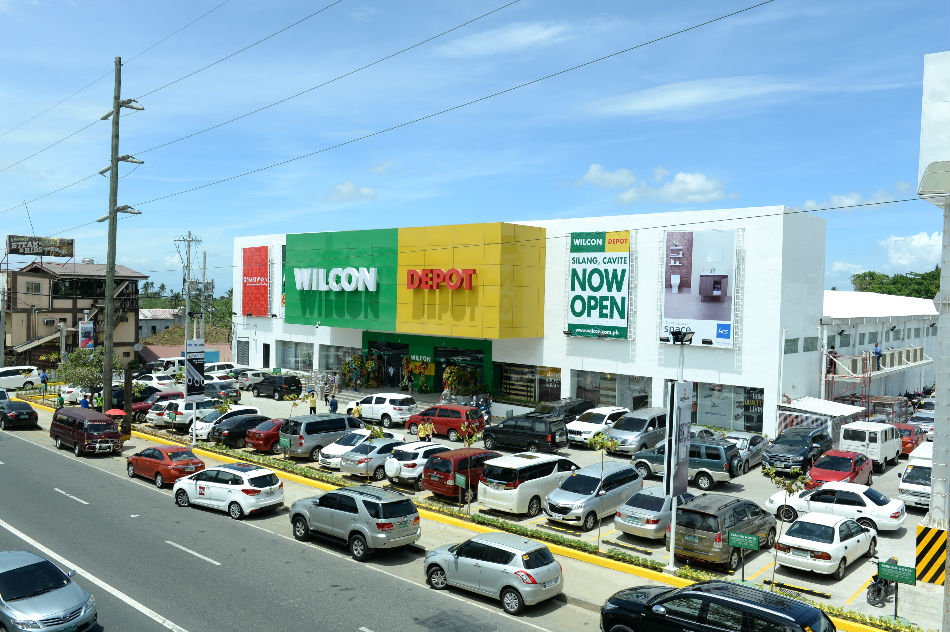Given the number of parked cars and visible people around the commercial building, what can be inferred about the popularity and potential business volume of the establishment on the day the photo was taken? The presence of a large number of parked cars and several people visible near the entrance of the commercial building suggests high customer turnout. This observation, combined with the 'NOW OPEN' banner, indicates that the establishment might have recently opened, attracting a surge of visitors eager to explore the new store. The high foot traffic and full parking lot imply that the establishment is quite popular and likely experiencing significant business volume on the day the photo was taken. 